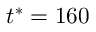<formula> <loc_0><loc_0><loc_500><loc_500>t ^ { * } = 1 6 0</formula> 